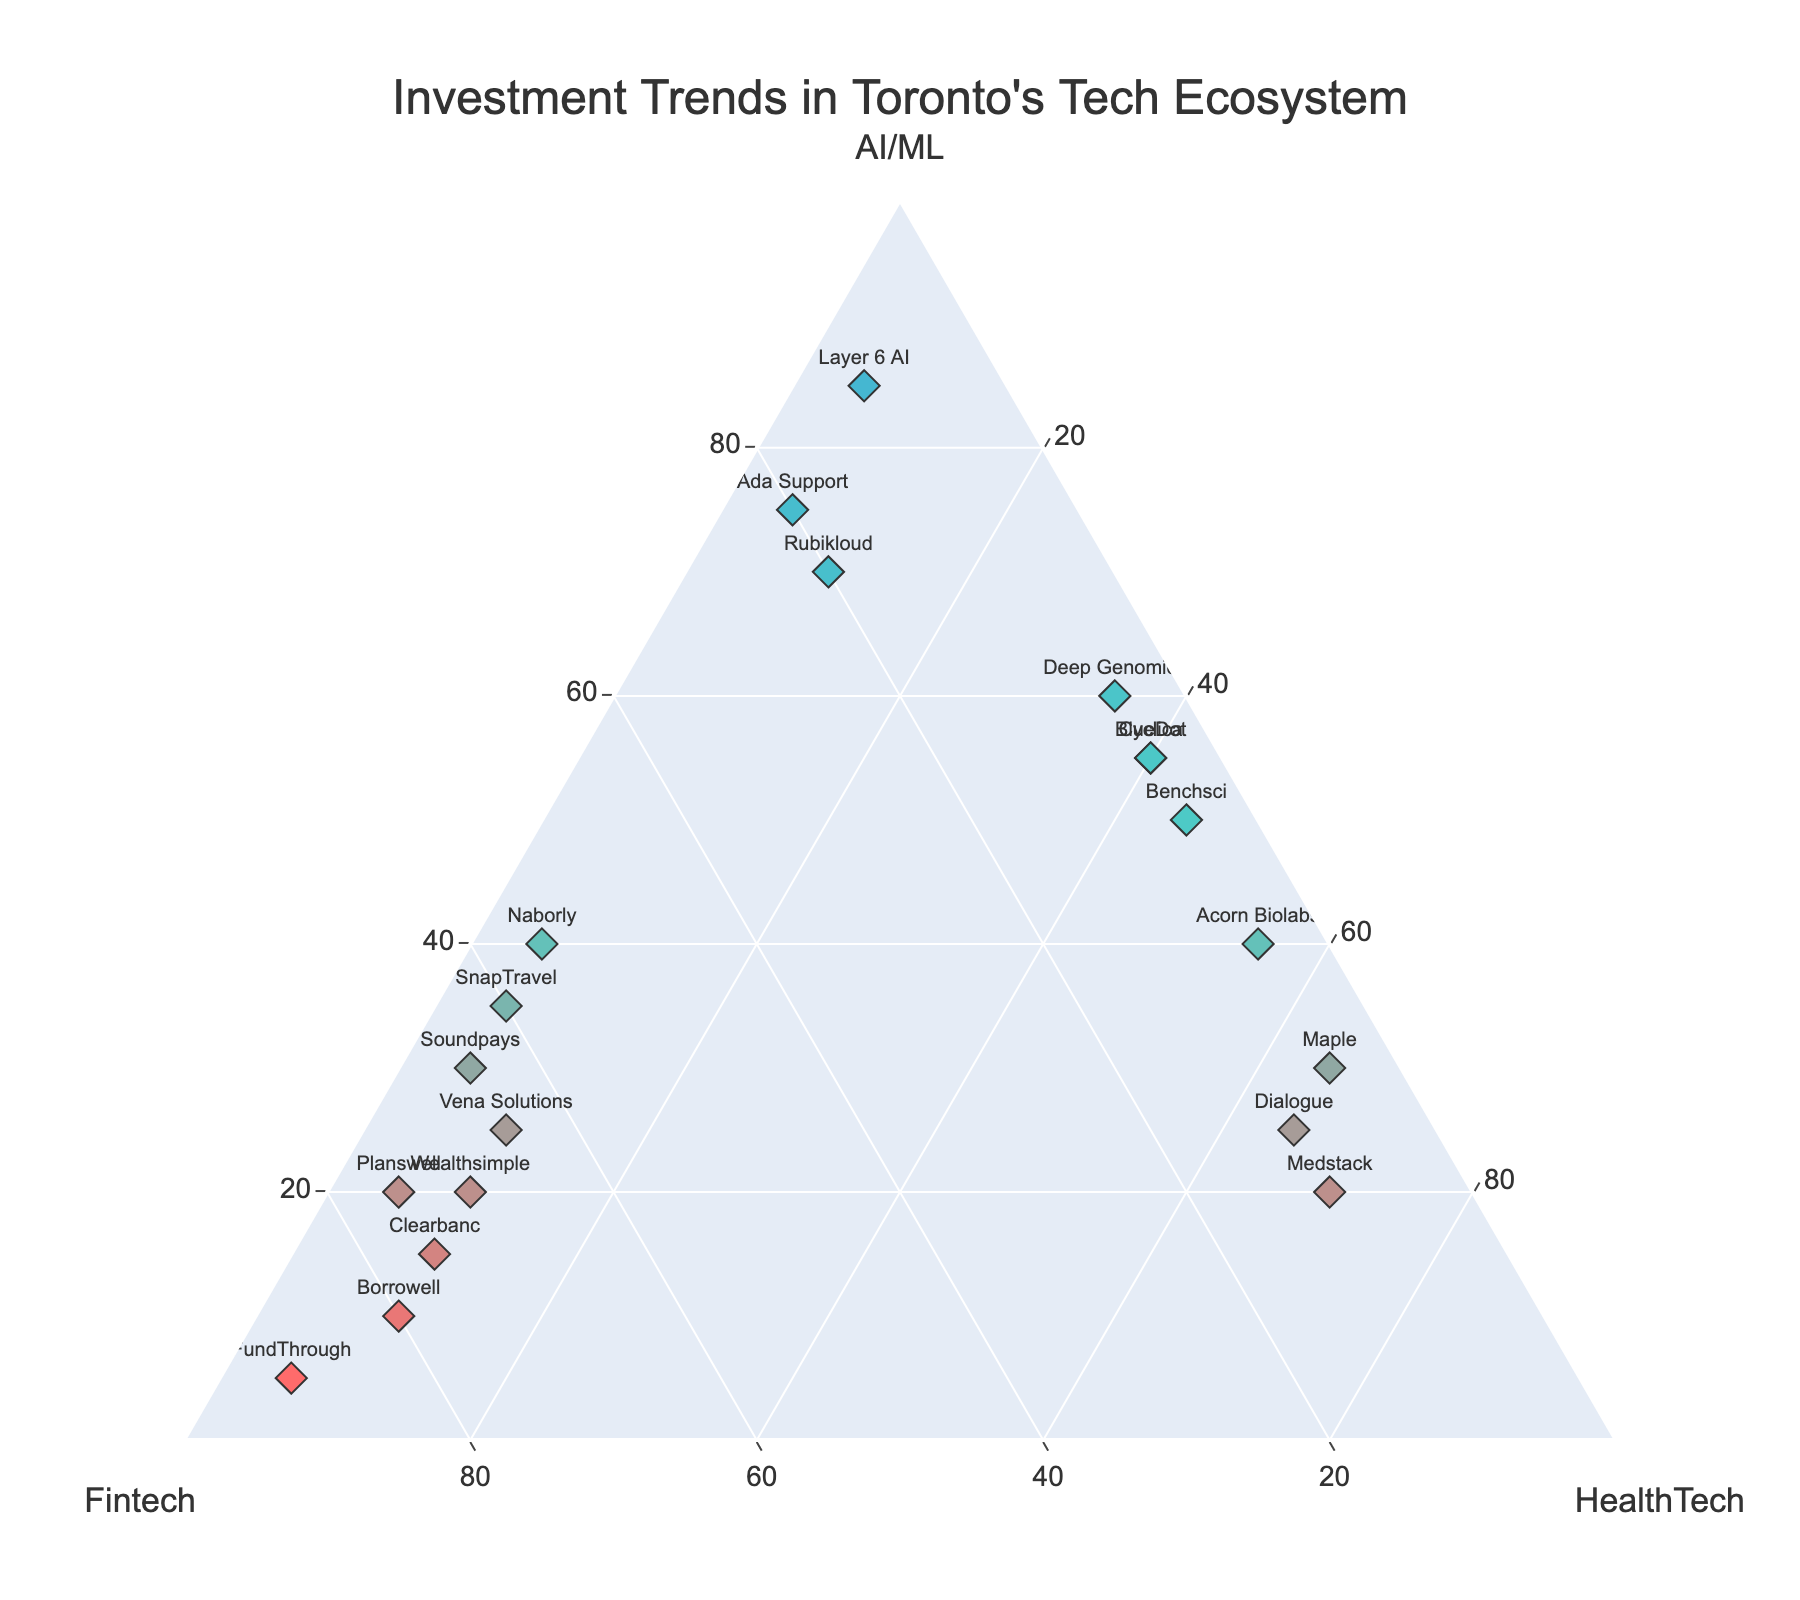What are the three sectors shown in the ternary plot? The ternary plot has three axes, each representing a different sector. The labels found on the axes are "AI/ML," "Fintech," and "HealthTech."
Answer: AI/ML, Fintech, HealthTech Which company has the highest allocation in AI/ML? Looking at the axis labeled "AI/ML," check for the data point furthest along this axis. "Layer 6 AI" is on the extreme end of the AI/ML axis with 85%.
Answer: Layer 6 AI What is the approximate allocation for Deep Genomics across the three sectors? Locate "Deep Genomics" on the plot. Its position relative to the axes indicates it has 60% in AI/ML, 5% in Fintech, and 35% in HealthTech.
Answer: AI/ML: 60%, Fintech: 5%, HealthTech: 35% How many companies have a higher allocation in HealthTech than in Fintech? To answer this, count the number of data points that are positioned closer to the "HealthTech" axis (or further from the Fintech axis) compared to the "Fintech" axis. Companies are: BlueDot, Medstack, Cyclica, Maple, Acorn Biolabs, Dialogue, Benchsci.
Answer: 7 companies Which companies have an equal allocation in Fintech and another sector? Look for data points where two of the percentage values are equal. "Borrowell," "Wealthsimple," and "Clearbanc" each have equal allocations in Fintech and HealthTech at 70%, 75%, and 65% respectively.
Answer: Borrowell, Wealthsimple, Clearbanc What is the average allocation for AI/ML across all companies? Sum all AI/ML percentages and divide by the number of companies. Sum: 20 + 60 + 10 + 55 + 15 + 85 + 30 + 70 + 25 + 50 + 40 + 35 + 20 + 55 + 5 + 20 + 40 + 25 + 30 + 75 = 825. Average is 825 / 20 = 41.25%.
Answer: 41.25% Which axis has the data point with the smallest allocation? Locate the smallest percentage along each axis. "FundThrough" has the smallest allocation in AI/ML with 5%, "Deep Genomics" and "BlueDot" have the smallest allocation in Fintech with 5%, and "Layer 6 AI" has the smallest allocation in HealthTech with 5%.
Answer: AI/ML: FundThrough, Fintech: Deep Genomics and BlueDot, HealthTech: Layer 6 AI Is there a company that has an equal allocation across all three sectors? Check if there is a data point where all three segments are equal. No company has an equal distribution among AI/ML, Fintech, and HealthTech.
Answer: No Which company is closest to the "HealthTech" apex? The point nearest to the "HealthTech" corner is high in HealthTech. "Medstack" positions itself closest with a 70% allocation in HealthTech.
Answer: Medstack 